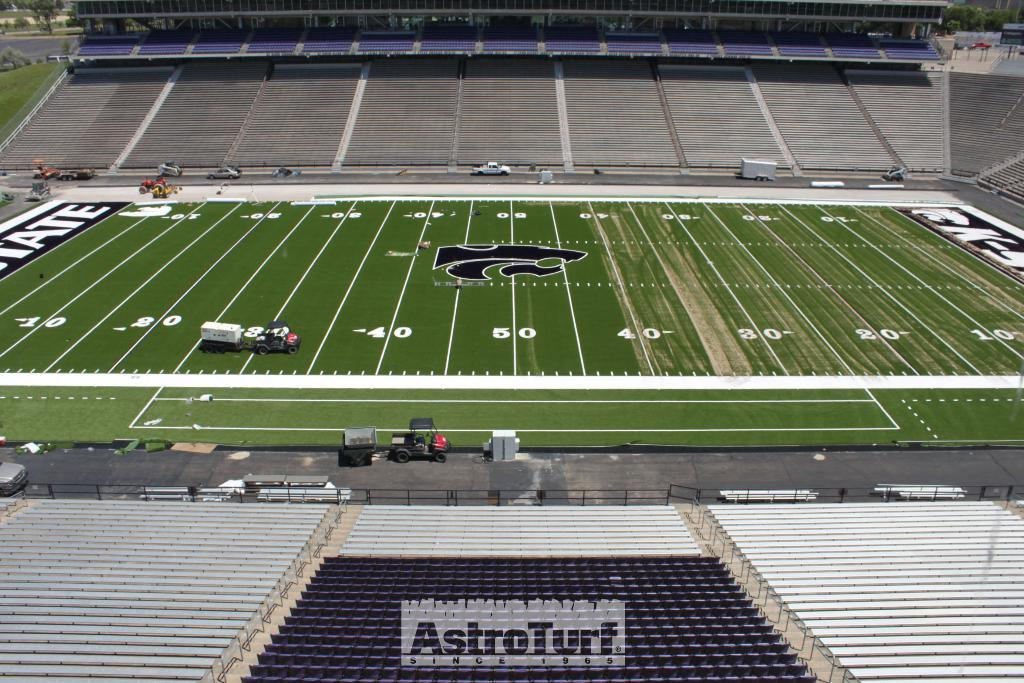<image>
Relay a brief, clear account of the picture shown. an Astro Turf since 1995 logo can be seen on the seats in the stadium 